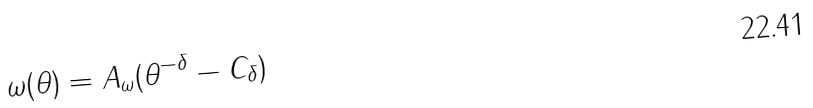Convert formula to latex. <formula><loc_0><loc_0><loc_500><loc_500>\omega ( \theta ) = A _ { \omega } ( \theta ^ { - \delta } - C _ { \delta } )</formula> 